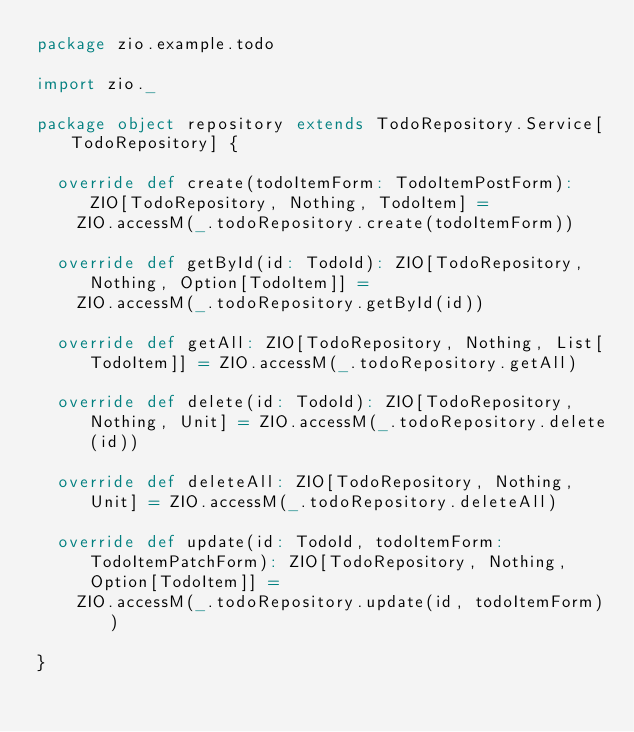Convert code to text. <code><loc_0><loc_0><loc_500><loc_500><_Scala_>package zio.example.todo

import zio._

package object repository extends TodoRepository.Service[TodoRepository] {

  override def create(todoItemForm: TodoItemPostForm): ZIO[TodoRepository, Nothing, TodoItem] =
    ZIO.accessM(_.todoRepository.create(todoItemForm))

  override def getById(id: TodoId): ZIO[TodoRepository, Nothing, Option[TodoItem]] =
    ZIO.accessM(_.todoRepository.getById(id))

  override def getAll: ZIO[TodoRepository, Nothing, List[TodoItem]] = ZIO.accessM(_.todoRepository.getAll)

  override def delete(id: TodoId): ZIO[TodoRepository, Nothing, Unit] = ZIO.accessM(_.todoRepository.delete(id))

  override def deleteAll: ZIO[TodoRepository, Nothing, Unit] = ZIO.accessM(_.todoRepository.deleteAll)

  override def update(id: TodoId, todoItemForm: TodoItemPatchForm): ZIO[TodoRepository, Nothing, Option[TodoItem]] =
    ZIO.accessM(_.todoRepository.update(id, todoItemForm))

}
</code> 